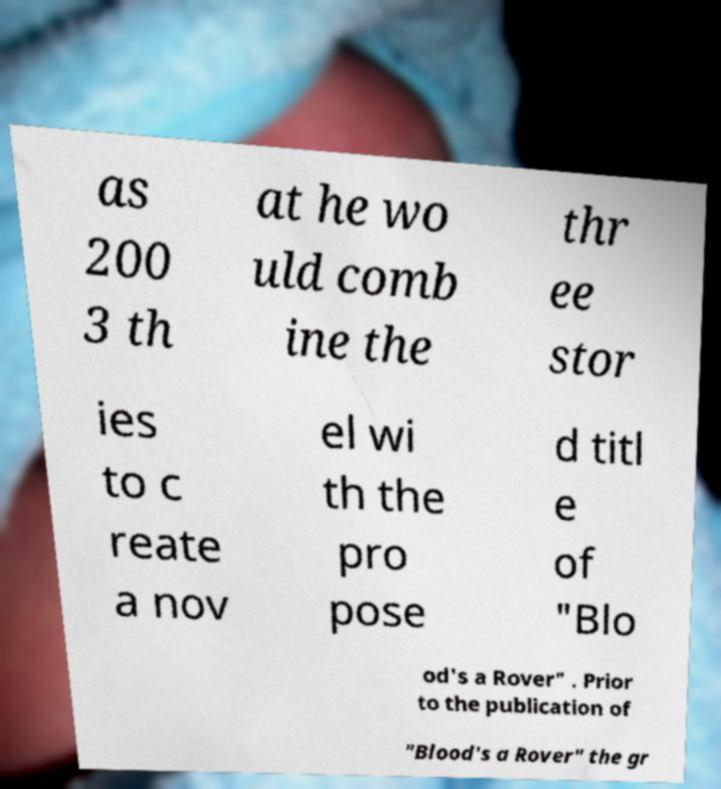What messages or text are displayed in this image? I need them in a readable, typed format. as 200 3 th at he wo uld comb ine the thr ee stor ies to c reate a nov el wi th the pro pose d titl e of "Blo od's a Rover" . Prior to the publication of "Blood's a Rover" the gr 